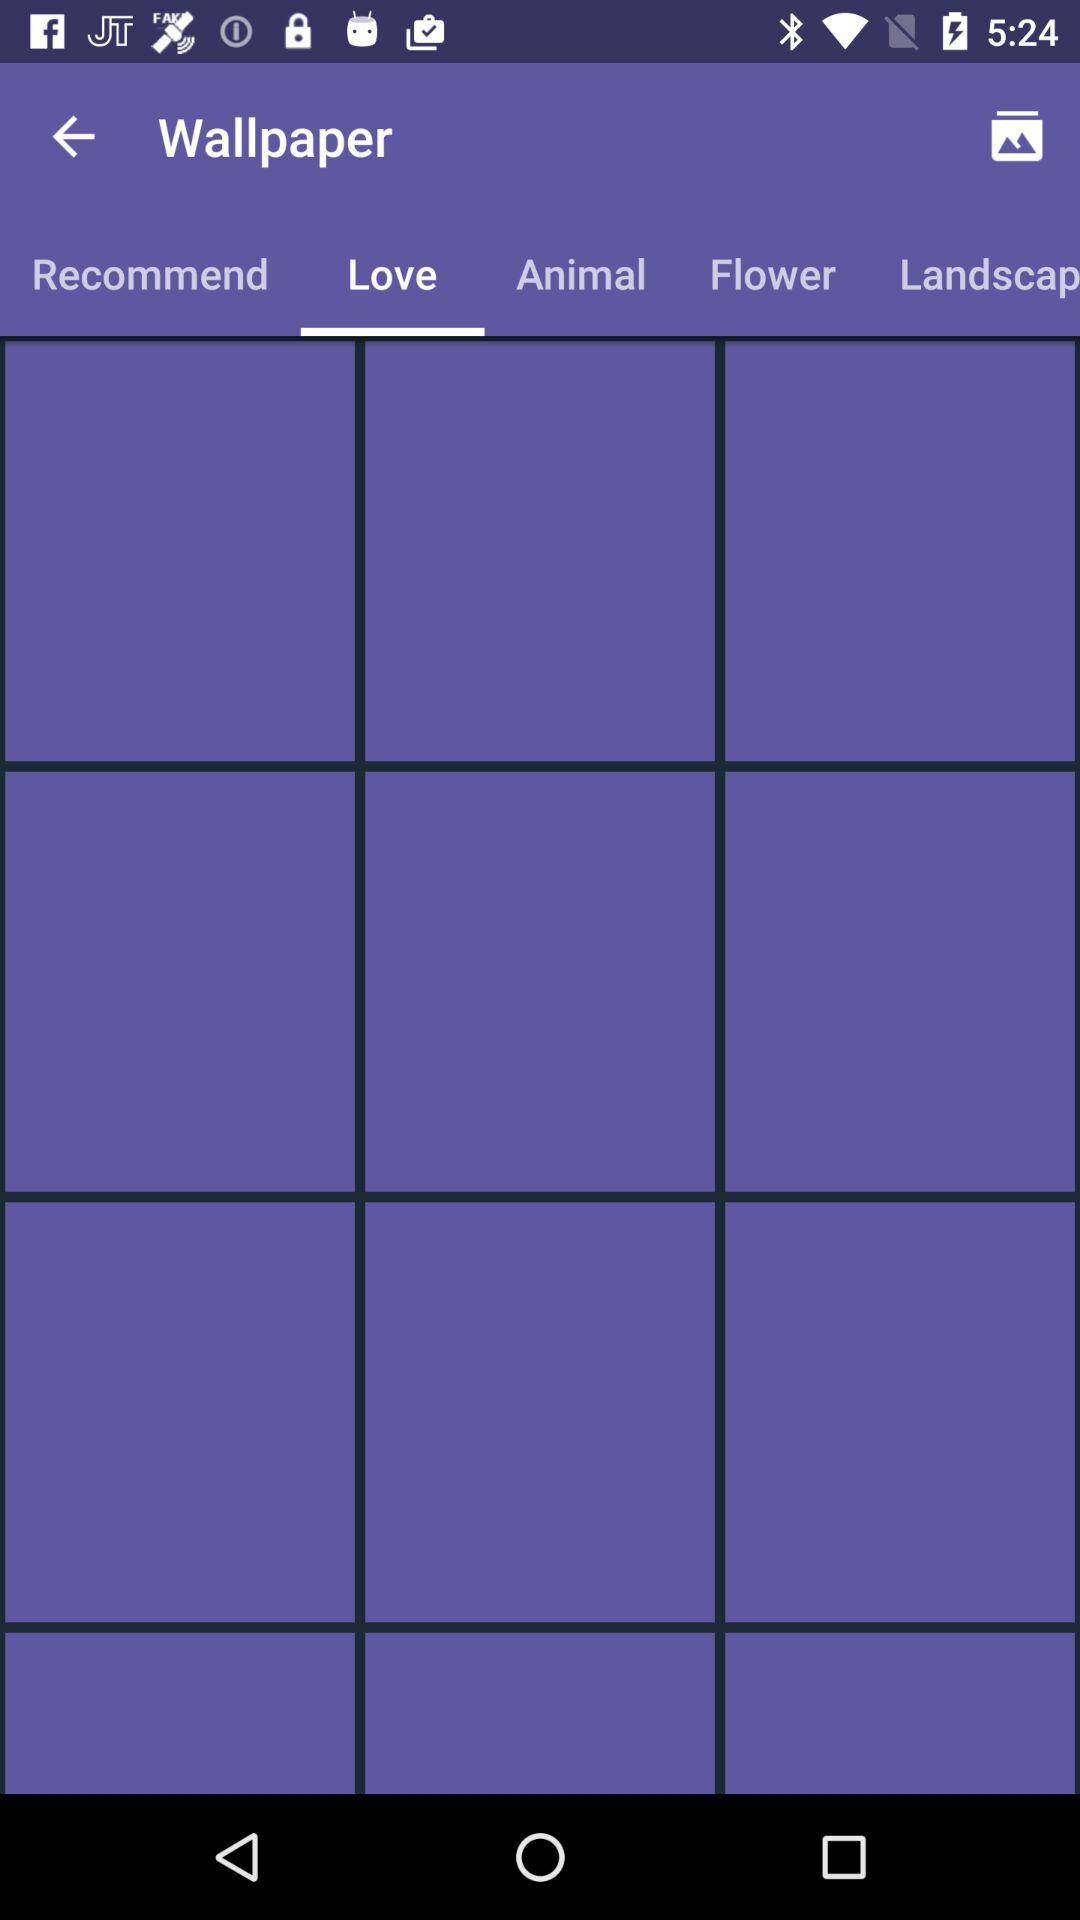What are the different categories of wallpaper listed? The different categories of wallpaper are "Recommend", "Love", "Animal" and "Flower". 